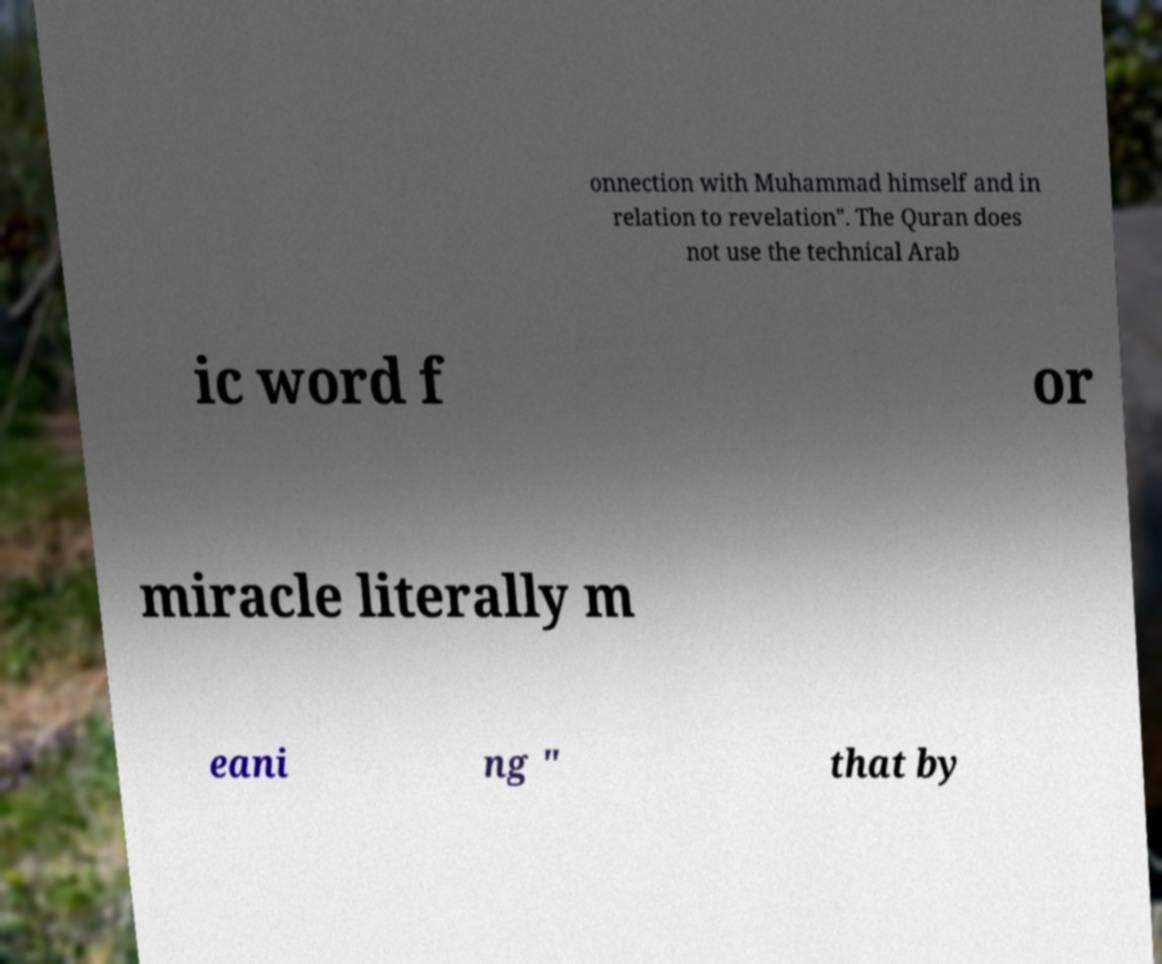There's text embedded in this image that I need extracted. Can you transcribe it verbatim? onnection with Muhammad himself and in relation to revelation". The Quran does not use the technical Arab ic word f or miracle literally m eani ng " that by 